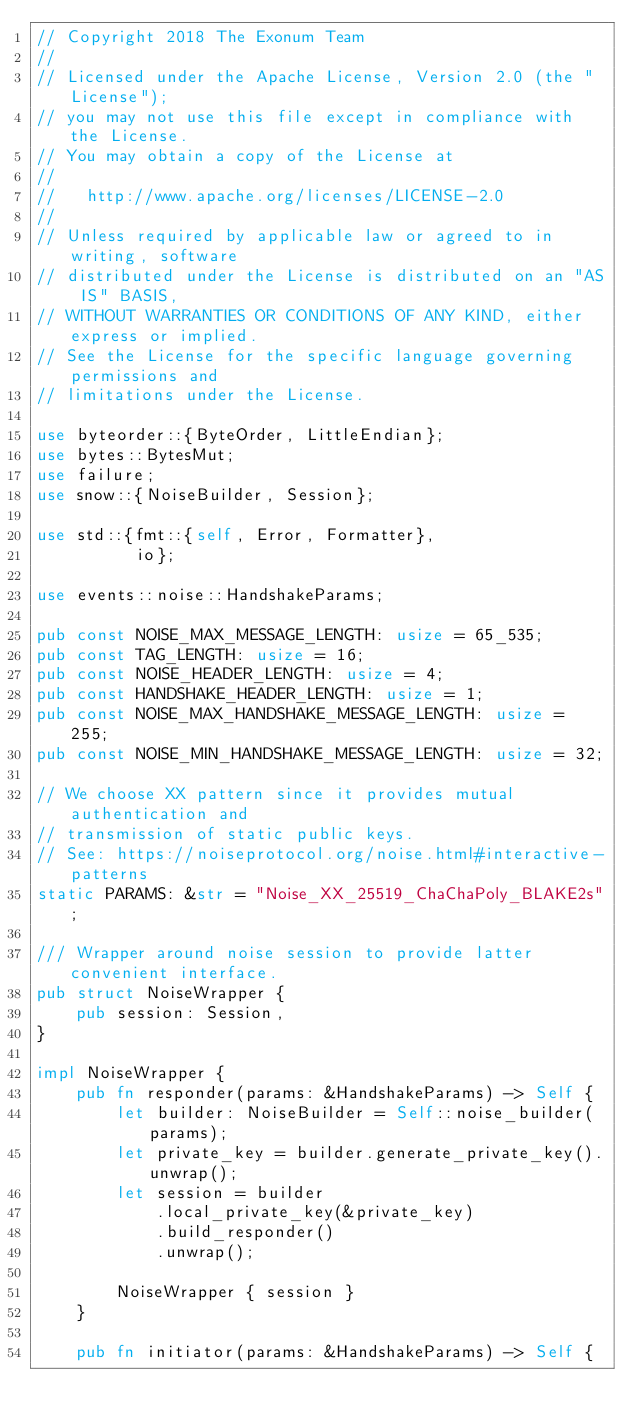<code> <loc_0><loc_0><loc_500><loc_500><_Rust_>// Copyright 2018 The Exonum Team
//
// Licensed under the Apache License, Version 2.0 (the "License");
// you may not use this file except in compliance with the License.
// You may obtain a copy of the License at
//
//   http://www.apache.org/licenses/LICENSE-2.0
//
// Unless required by applicable law or agreed to in writing, software
// distributed under the License is distributed on an "AS IS" BASIS,
// WITHOUT WARRANTIES OR CONDITIONS OF ANY KIND, either express or implied.
// See the License for the specific language governing permissions and
// limitations under the License.

use byteorder::{ByteOrder, LittleEndian};
use bytes::BytesMut;
use failure;
use snow::{NoiseBuilder, Session};

use std::{fmt::{self, Error, Formatter},
          io};

use events::noise::HandshakeParams;

pub const NOISE_MAX_MESSAGE_LENGTH: usize = 65_535;
pub const TAG_LENGTH: usize = 16;
pub const NOISE_HEADER_LENGTH: usize = 4;
pub const HANDSHAKE_HEADER_LENGTH: usize = 1;
pub const NOISE_MAX_HANDSHAKE_MESSAGE_LENGTH: usize = 255;
pub const NOISE_MIN_HANDSHAKE_MESSAGE_LENGTH: usize = 32;

// We choose XX pattern since it provides mutual authentication and
// transmission of static public keys.
// See: https://noiseprotocol.org/noise.html#interactive-patterns
static PARAMS: &str = "Noise_XX_25519_ChaChaPoly_BLAKE2s";

/// Wrapper around noise session to provide latter convenient interface.
pub struct NoiseWrapper {
    pub session: Session,
}

impl NoiseWrapper {
    pub fn responder(params: &HandshakeParams) -> Self {
        let builder: NoiseBuilder = Self::noise_builder(params);
        let private_key = builder.generate_private_key().unwrap();
        let session = builder
            .local_private_key(&private_key)
            .build_responder()
            .unwrap();

        NoiseWrapper { session }
    }

    pub fn initiator(params: &HandshakeParams) -> Self {</code> 